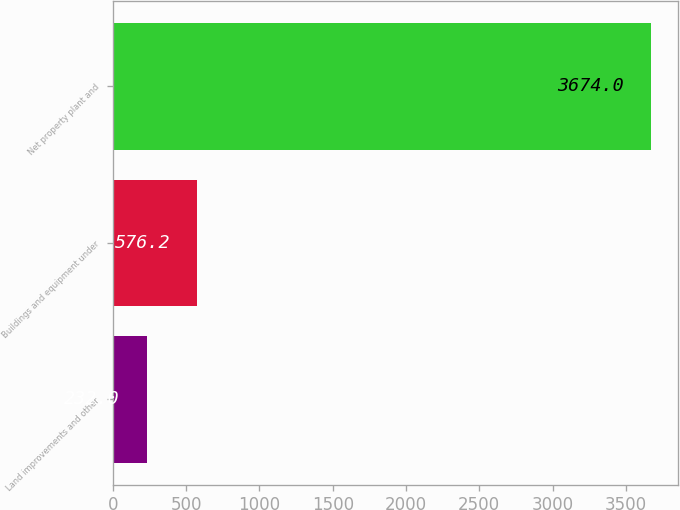Convert chart. <chart><loc_0><loc_0><loc_500><loc_500><bar_chart><fcel>Land improvements and other<fcel>Buildings and equipment under<fcel>Net property plant and<nl><fcel>232<fcel>576.2<fcel>3674<nl></chart> 